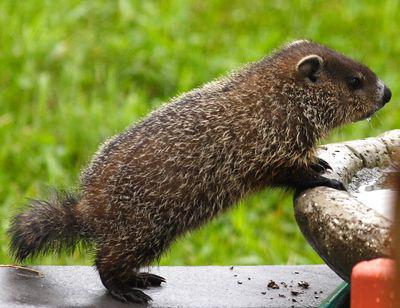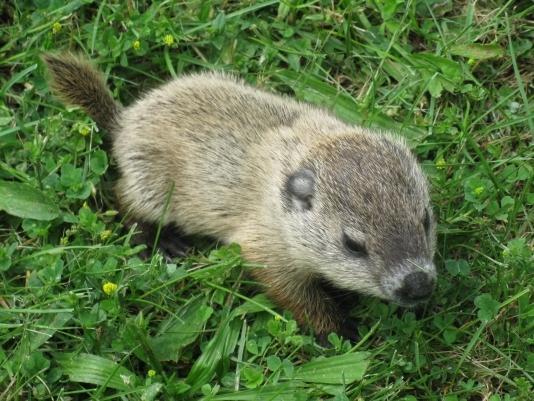The first image is the image on the left, the second image is the image on the right. For the images displayed, is the sentence "There is one image that does not include green vegetation in the background." factually correct? Answer yes or no. No. The first image is the image on the left, the second image is the image on the right. Analyze the images presented: Is the assertion "The left image includes a right-facing marmot with its front paws propped up on something." valid? Answer yes or no. Yes. 